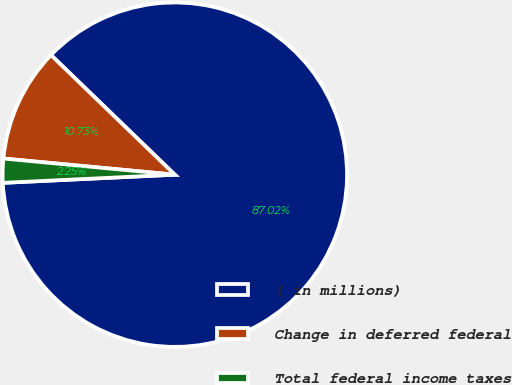<chart> <loc_0><loc_0><loc_500><loc_500><pie_chart><fcel>( in millions)<fcel>Change in deferred federal<fcel>Total federal income taxes<nl><fcel>87.02%<fcel>10.73%<fcel>2.25%<nl></chart> 